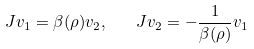Convert formula to latex. <formula><loc_0><loc_0><loc_500><loc_500>J v _ { 1 } = \beta ( \rho ) v _ { 2 } , \quad J v _ { 2 } = - \frac { 1 } { \beta ( \rho ) } v _ { 1 }</formula> 